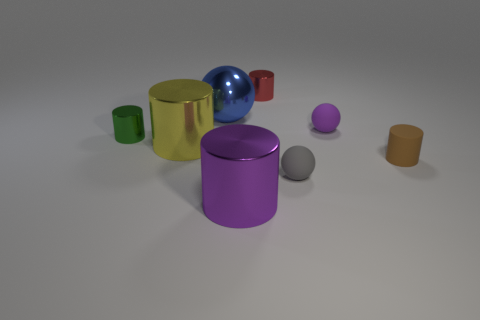There is a purple thing in front of the tiny purple ball; what is its size?
Your response must be concise. Large. What is the material of the small ball that is in front of the tiny ball behind the matte cylinder?
Your response must be concise. Rubber. There is a large thing that is in front of the small gray matte ball; is its color the same as the big metal sphere?
Ensure brevity in your answer.  No. Is there any other thing that has the same material as the small gray object?
Offer a terse response. Yes. How many brown things have the same shape as the tiny gray thing?
Your answer should be compact. 0. What is the size of the red object that is made of the same material as the green cylinder?
Ensure brevity in your answer.  Small. There is a large cylinder that is behind the big cylinder in front of the big yellow thing; is there a small red metallic cylinder that is left of it?
Ensure brevity in your answer.  No. Is the size of the metallic cylinder that is behind the green object the same as the metallic ball?
Your response must be concise. No. How many matte things are the same size as the purple rubber ball?
Ensure brevity in your answer.  2. Do the small rubber cylinder and the metallic ball have the same color?
Provide a short and direct response. No. 